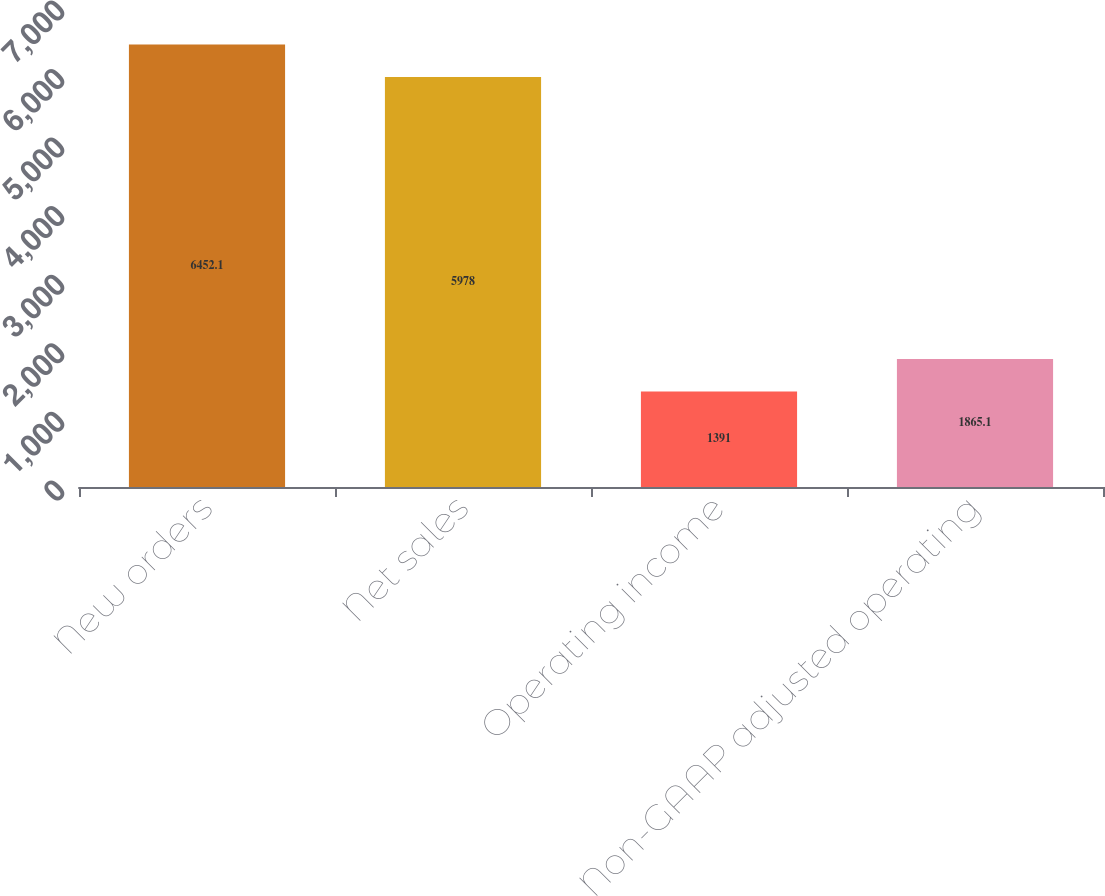<chart> <loc_0><loc_0><loc_500><loc_500><bar_chart><fcel>New orders<fcel>Net sales<fcel>Operating income<fcel>Non-GAAP adjusted operating<nl><fcel>6452.1<fcel>5978<fcel>1391<fcel>1865.1<nl></chart> 